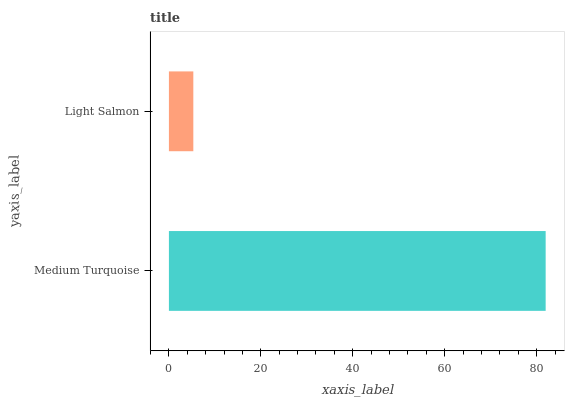Is Light Salmon the minimum?
Answer yes or no. Yes. Is Medium Turquoise the maximum?
Answer yes or no. Yes. Is Light Salmon the maximum?
Answer yes or no. No. Is Medium Turquoise greater than Light Salmon?
Answer yes or no. Yes. Is Light Salmon less than Medium Turquoise?
Answer yes or no. Yes. Is Light Salmon greater than Medium Turquoise?
Answer yes or no. No. Is Medium Turquoise less than Light Salmon?
Answer yes or no. No. Is Medium Turquoise the high median?
Answer yes or no. Yes. Is Light Salmon the low median?
Answer yes or no. Yes. Is Light Salmon the high median?
Answer yes or no. No. Is Medium Turquoise the low median?
Answer yes or no. No. 